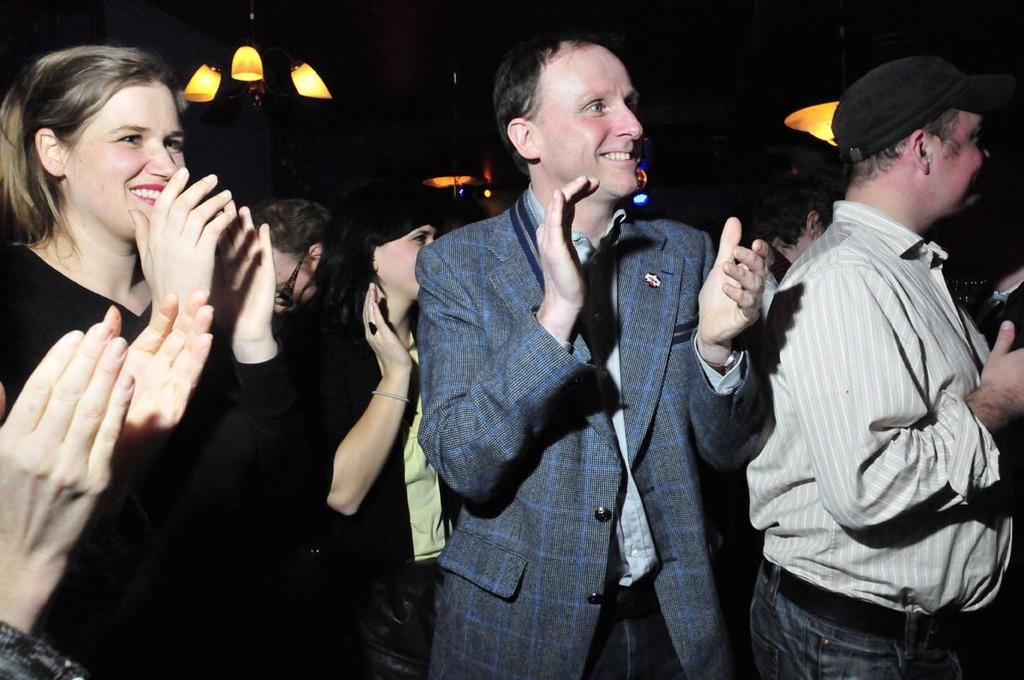What is happening in the image involving the group of people? The people in the image are standing and clapping. How are the people in the front of the group expressing their emotions? The persons in the front are smiling. What can be seen in the background of the image? There are lights visible in the background of the image. What type of pet is sitting on the stone in the image? There is no pet or stone present in the image. How does the group of people move around in the image? The group of people is not moving around in the image; they are standing and clapping in place. 